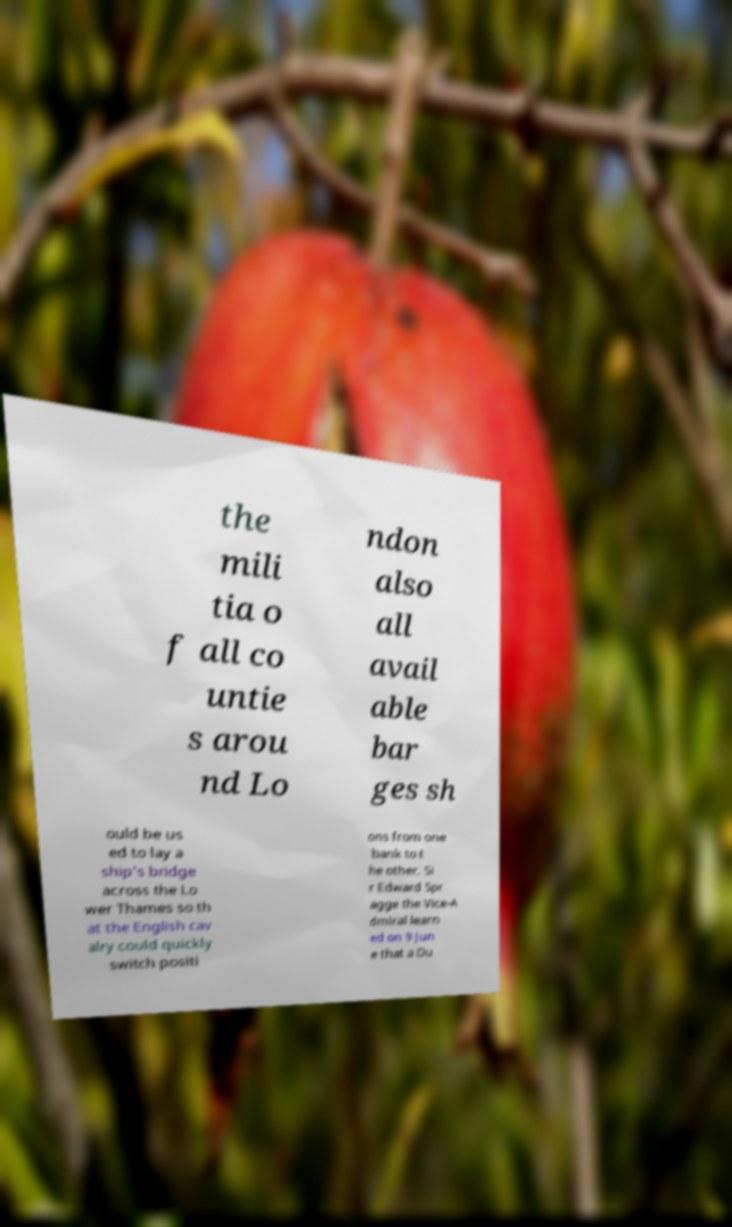Please identify and transcribe the text found in this image. the mili tia o f all co untie s arou nd Lo ndon also all avail able bar ges sh ould be us ed to lay a ship's bridge across the Lo wer Thames so th at the English cav alry could quickly switch positi ons from one bank to t he other. Si r Edward Spr agge the Vice-A dmiral learn ed on 9 Jun e that a Du 